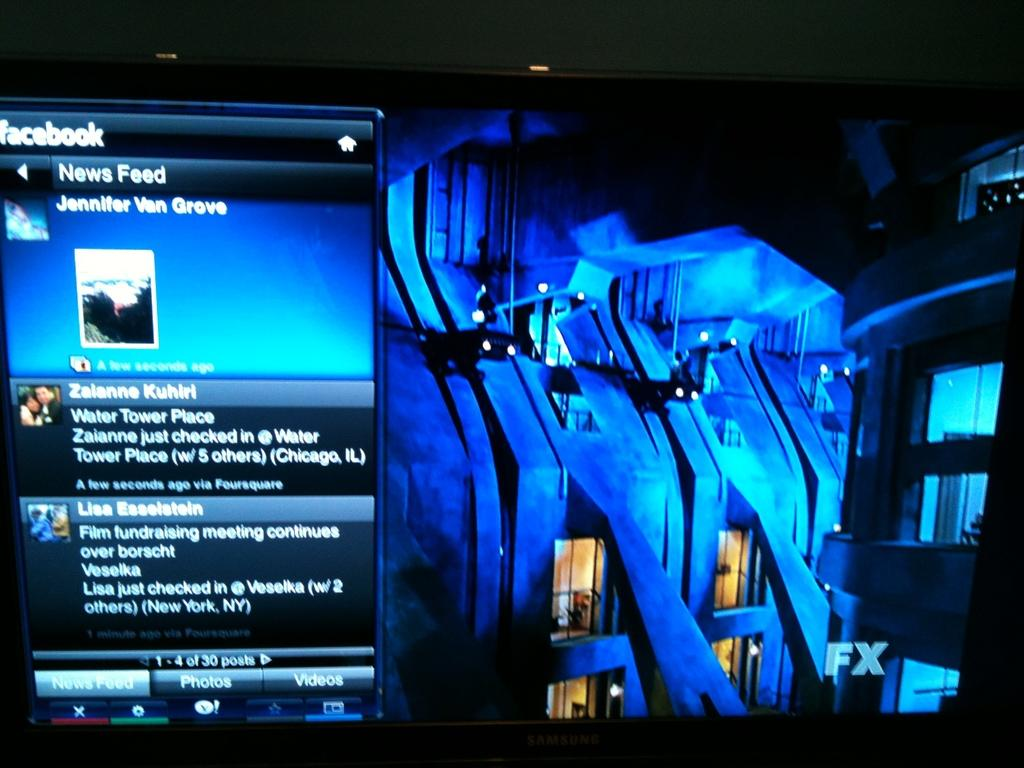<image>
Create a compact narrative representing the image presented. A phone that is showing a face book page with a news feed for Jennifer Van Grove. 